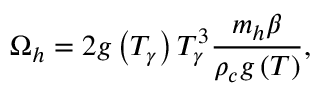Convert formula to latex. <formula><loc_0><loc_0><loc_500><loc_500>\Omega _ { h } = 2 g \left ( T _ { \gamma } \right ) T _ { \gamma } ^ { 3 } \frac { m _ { h } \beta } { \rho _ { c } g \left ( T \right ) } ,</formula> 